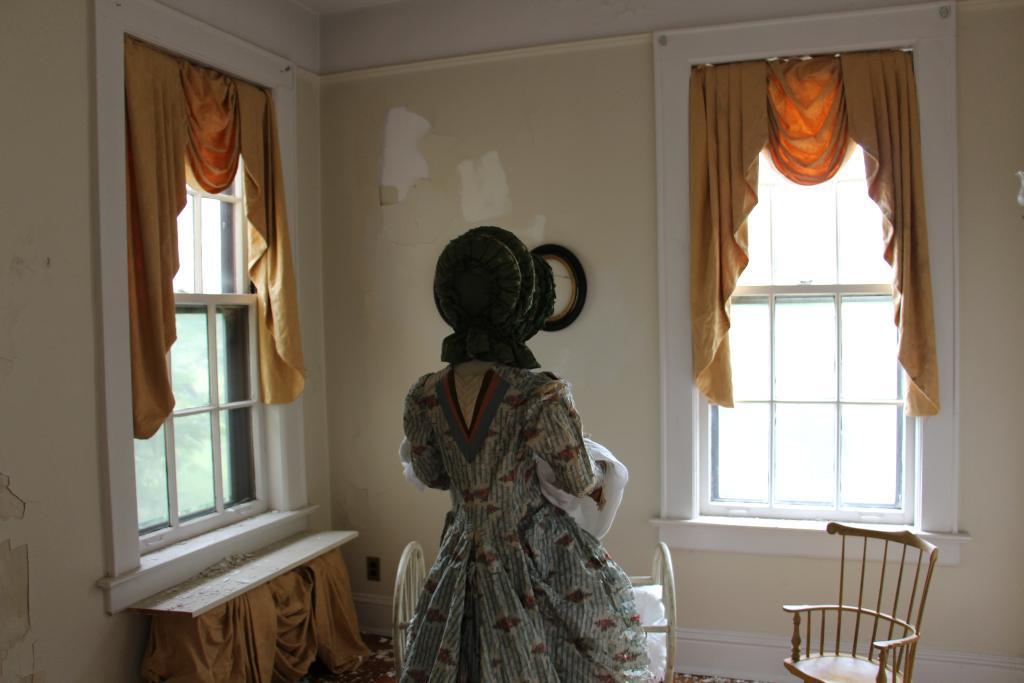Could you give a brief overview of what you see in this image? In this picture we can see all, windows with curtains. We can see chairs here on the floor and one person is standing. 